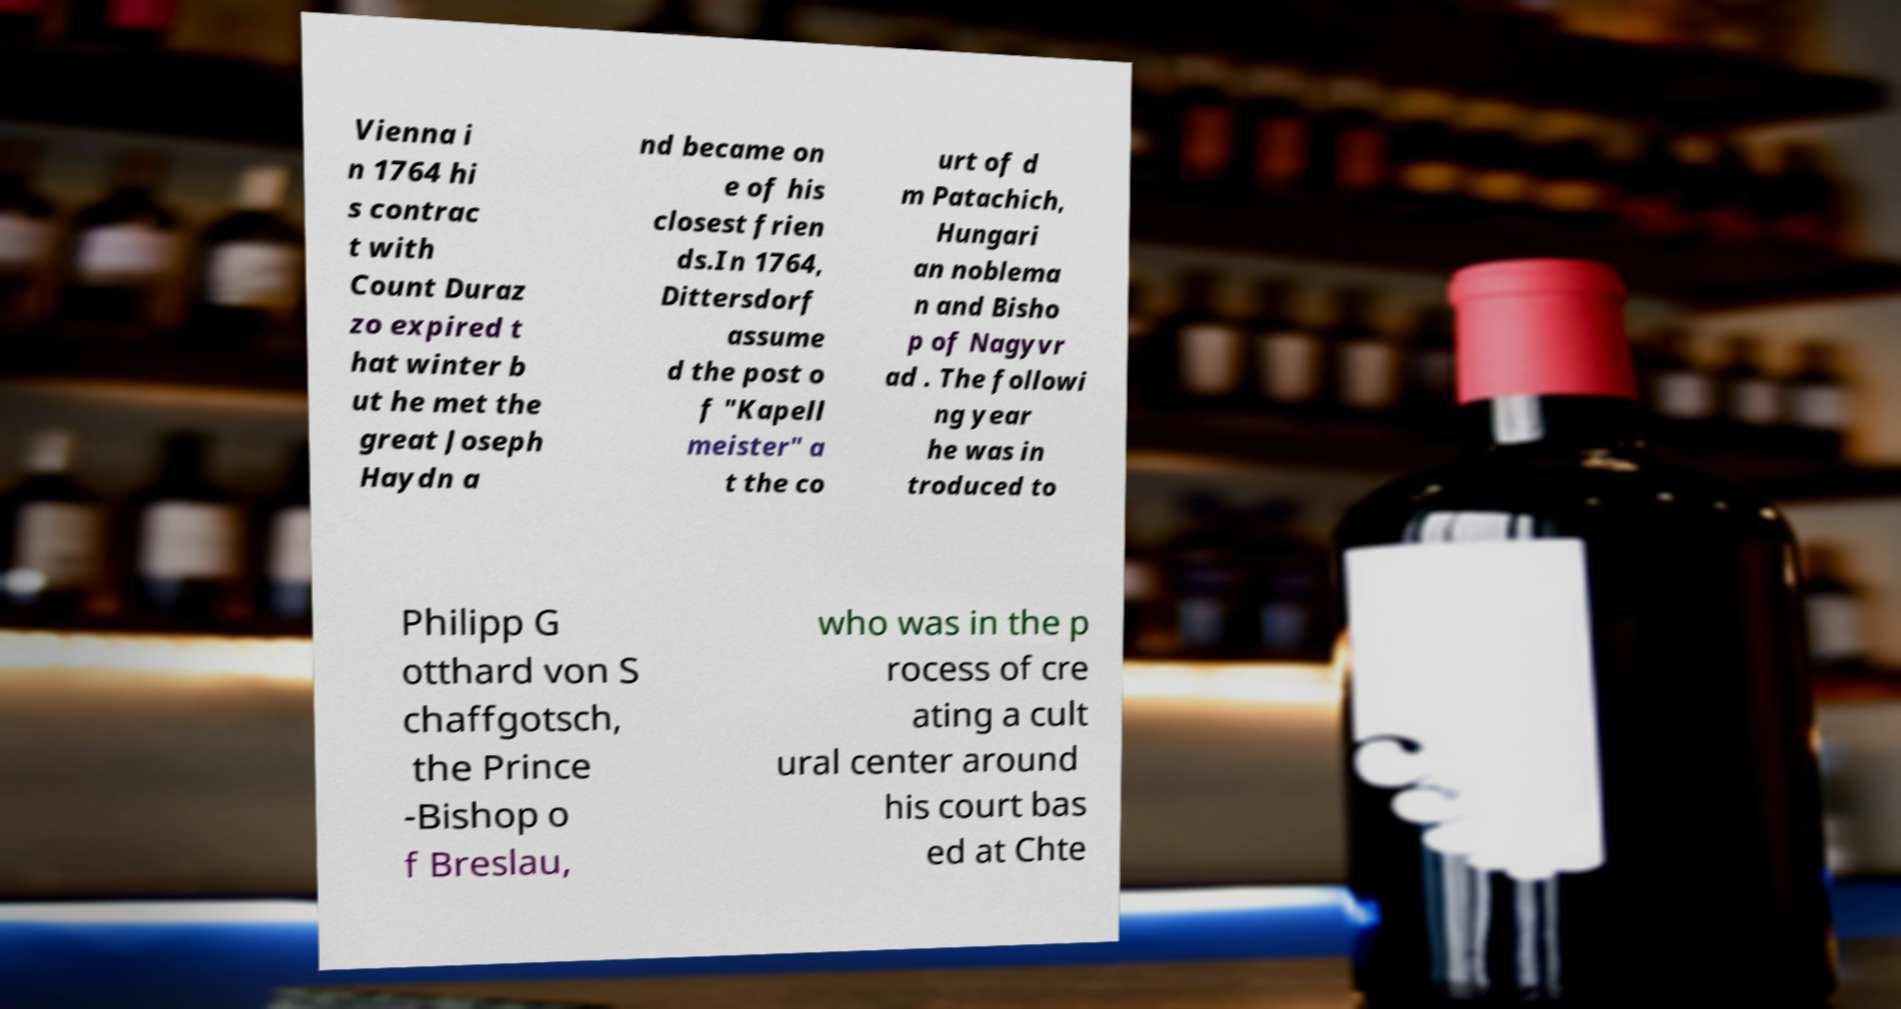Please read and relay the text visible in this image. What does it say? Vienna i n 1764 hi s contrac t with Count Duraz zo expired t hat winter b ut he met the great Joseph Haydn a nd became on e of his closest frien ds.In 1764, Dittersdorf assume d the post o f "Kapell meister" a t the co urt of d m Patachich, Hungari an noblema n and Bisho p of Nagyvr ad . The followi ng year he was in troduced to Philipp G otthard von S chaffgotsch, the Prince -Bishop o f Breslau, who was in the p rocess of cre ating a cult ural center around his court bas ed at Chte 